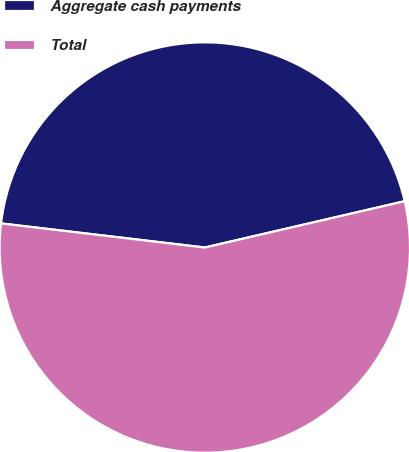Convert chart to OTSL. <chart><loc_0><loc_0><loc_500><loc_500><pie_chart><fcel>Aggregate cash payments<fcel>Total<nl><fcel>44.5%<fcel>55.5%<nl></chart> 